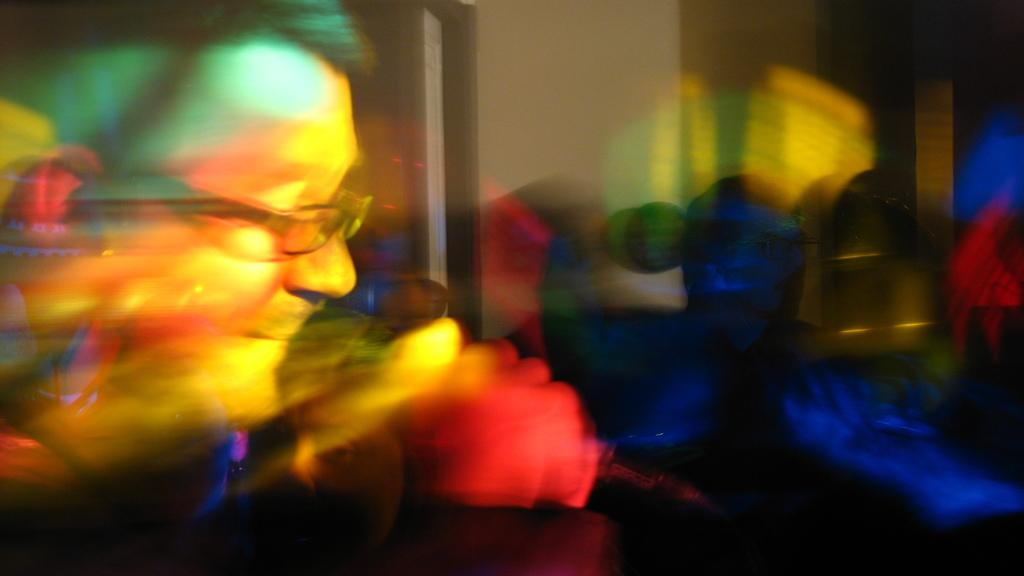Who is present in the image? There is a man in the image. Where is the man located in the image? The man is on the left side of the image. What accessory is the man wearing? The man is wearing spectacles. Can you describe the background of the image? The background of the image is blurry. What type of ornament is the man holding in the image? There is no ornament present in the image. Is the man taking a picture of the background with a camera in the image? There is no camera visible in the image, and the man is not taking a picture. 